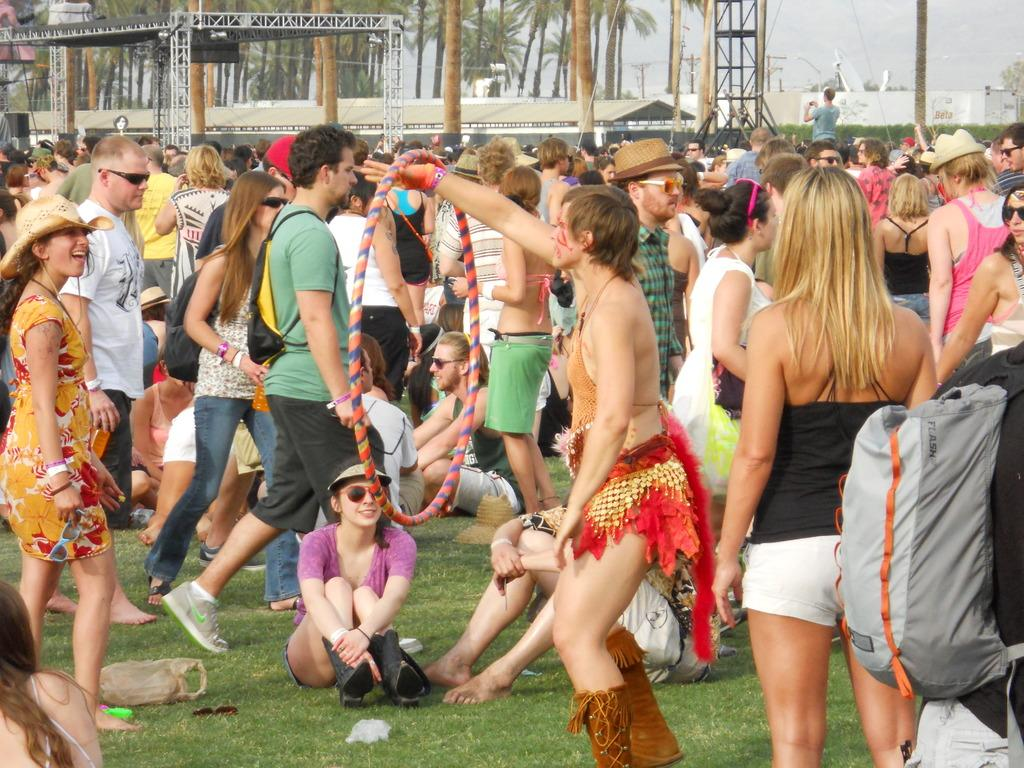What are the people in the image doing? There is a group of people standing on the ground in the image. What type of vegetation can be seen in the image? There is grass and trees in the image. What is the purpose of the electric pole in the image? The electric pole is likely used for providing electricity to the area. What can be seen in the sky in the image? The sky is visible in the image. What type of science experiment is being conducted by the people in the image? There is no indication of a science experiment being conducted in the image; the people are simply standing on the ground. 